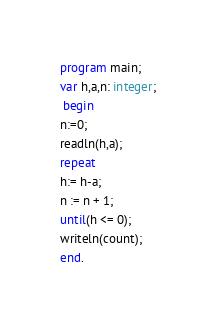<code> <loc_0><loc_0><loc_500><loc_500><_Pascal_>program main;
var h,a,n: integer;
 begin
n:=0;
readln(h,a);
repeat
h:= h-a;
n := n + 1;
until(h <= 0);
writeln(count);
end.</code> 